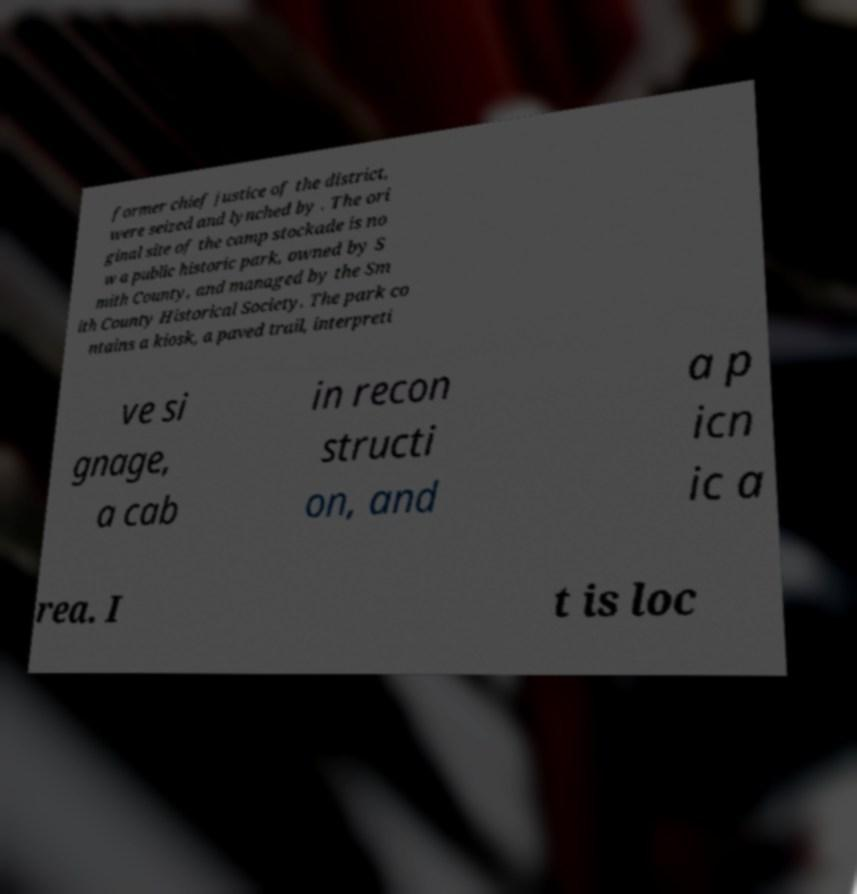Could you assist in decoding the text presented in this image and type it out clearly? former chief justice of the district, were seized and lynched by . The ori ginal site of the camp stockade is no w a public historic park, owned by S mith County, and managed by the Sm ith County Historical Society. The park co ntains a kiosk, a paved trail, interpreti ve si gnage, a cab in recon structi on, and a p icn ic a rea. I t is loc 